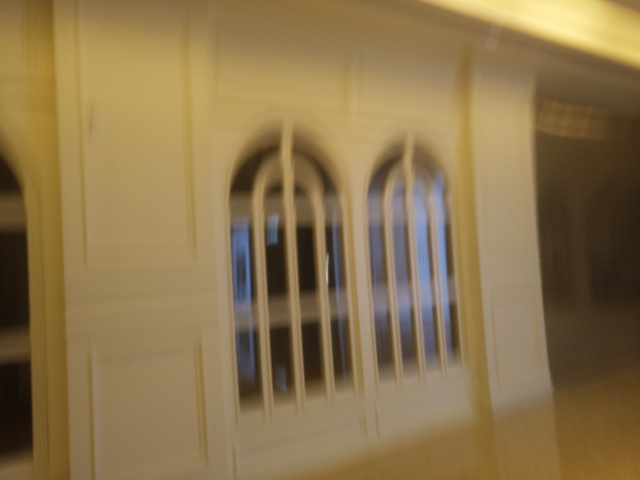What is the possible historical significance of this structure? The style of the windows suggests gothic or neo-gothic influence, commonly seen in buildings constructed in the late 19th to early 20th century. While the blurriness of the image prevents a detailed analysis, such structures often have historical significance as examples of their architectural period's craftsmanship and artistic trends. 